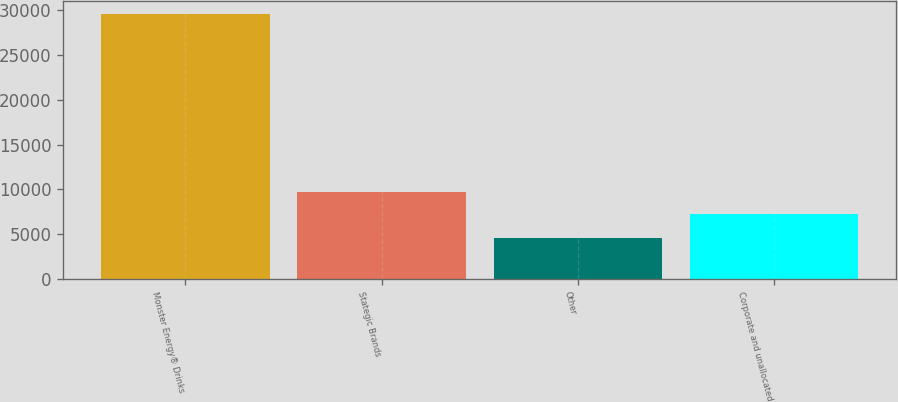<chart> <loc_0><loc_0><loc_500><loc_500><bar_chart><fcel>Monster Energy® Drinks<fcel>Stategic Brands<fcel>Other<fcel>Corporate and unallocated<nl><fcel>29591<fcel>9743.3<fcel>4608<fcel>7245<nl></chart> 